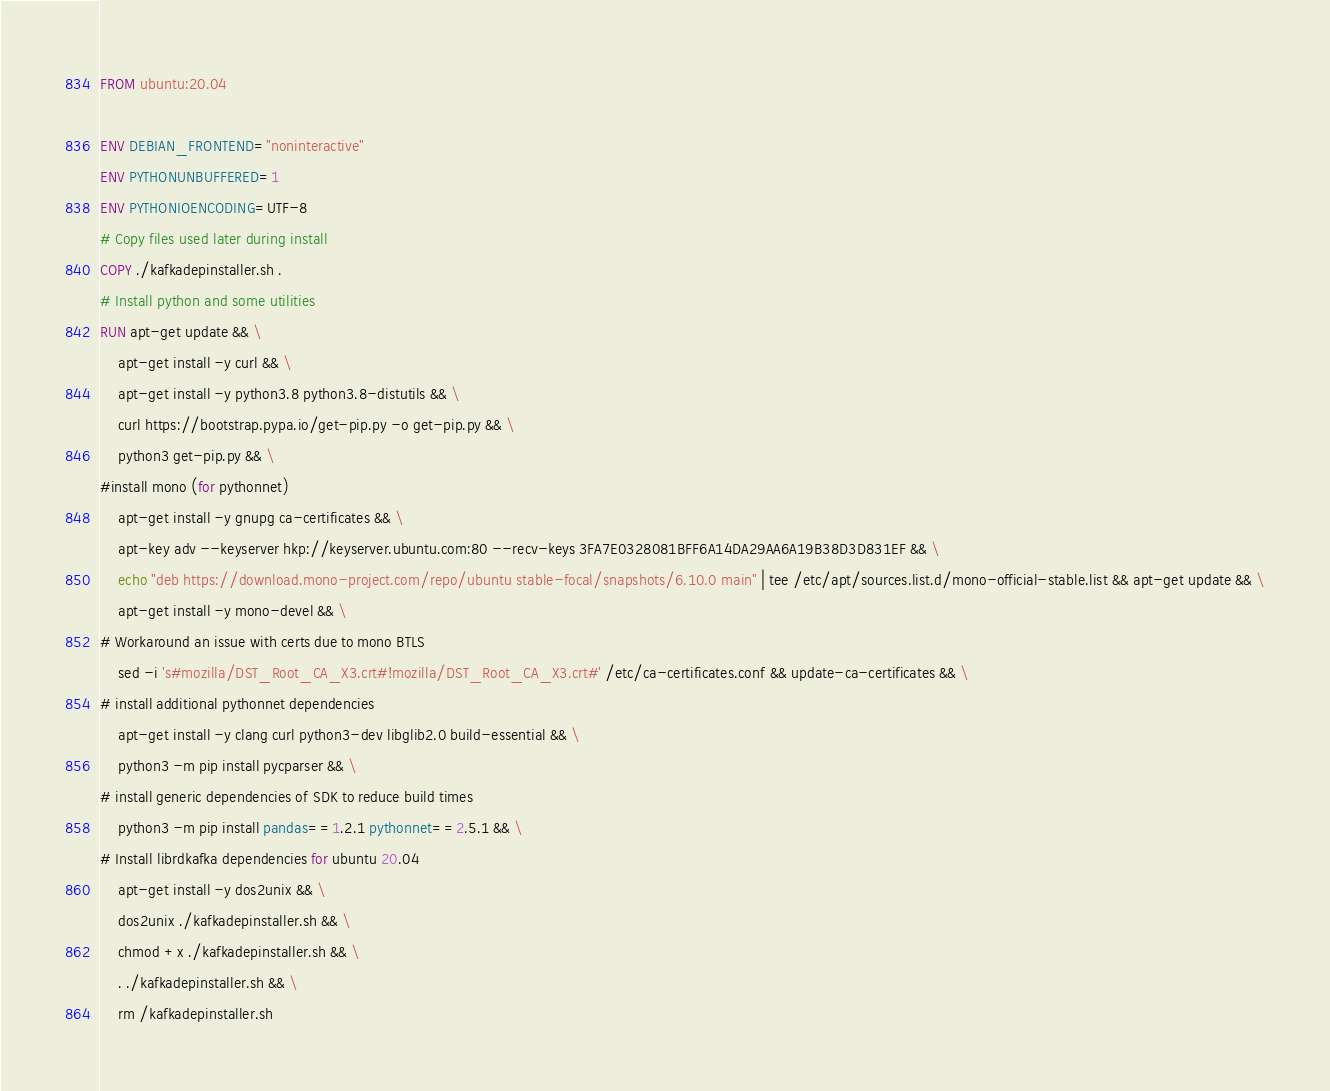<code> <loc_0><loc_0><loc_500><loc_500><_Dockerfile_>FROM ubuntu:20.04

ENV DEBIAN_FRONTEND="noninteractive"
ENV PYTHONUNBUFFERED=1
ENV PYTHONIOENCODING=UTF-8
# Copy files used later during install
COPY ./kafkadepinstaller.sh .
# Install python and some utilities
RUN apt-get update && \
    apt-get install -y curl && \
    apt-get install -y python3.8 python3.8-distutils && \
    curl https://bootstrap.pypa.io/get-pip.py -o get-pip.py && \
    python3 get-pip.py && \
#install mono (for pythonnet)
    apt-get install -y gnupg ca-certificates && \
    apt-key adv --keyserver hkp://keyserver.ubuntu.com:80 --recv-keys 3FA7E0328081BFF6A14DA29AA6A19B38D3D831EF && \
    echo "deb https://download.mono-project.com/repo/ubuntu stable-focal/snapshots/6.10.0 main" | tee /etc/apt/sources.list.d/mono-official-stable.list && apt-get update && \
    apt-get install -y mono-devel && \
# Workaround an issue with certs due to mono BTLS
    sed -i 's#mozilla/DST_Root_CA_X3.crt#!mozilla/DST_Root_CA_X3.crt#' /etc/ca-certificates.conf && update-ca-certificates && \
# install additional pythonnet dependencies
    apt-get install -y clang curl python3-dev libglib2.0 build-essential && \
    python3 -m pip install pycparser && \
# install generic dependencies of SDK to reduce build times
    python3 -m pip install pandas==1.2.1 pythonnet==2.5.1 && \
# Install librdkafka dependencies for ubuntu 20.04
    apt-get install -y dos2unix && \
    dos2unix ./kafkadepinstaller.sh && \
    chmod +x ./kafkadepinstaller.sh && \
    . ./kafkadepinstaller.sh && \
    rm /kafkadepinstaller.sh</code> 